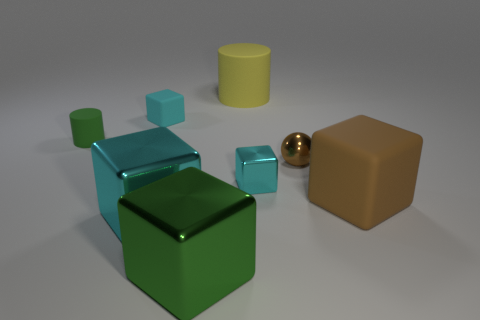Subtract all brown blocks. How many blocks are left? 4 Subtract all tiny cyan cubes. How many cubes are left? 3 Subtract all cylinders. How many objects are left? 6 Add 3 tiny green cylinders. How many tiny green cylinders exist? 4 Add 1 big yellow rubber cylinders. How many objects exist? 9 Subtract 0 blue cylinders. How many objects are left? 8 Subtract 2 cubes. How many cubes are left? 3 Subtract all blue spheres. Subtract all red cylinders. How many spheres are left? 1 Subtract all green cylinders. How many cyan cubes are left? 3 Subtract all small brown metallic balls. Subtract all tiny cubes. How many objects are left? 5 